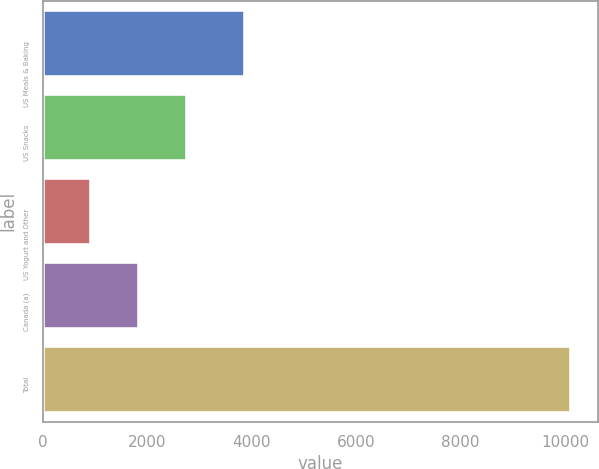Convert chart to OTSL. <chart><loc_0><loc_0><loc_500><loc_500><bar_chart><fcel>US Meals & Baking<fcel>US Snacks<fcel>US Yogurt and Other<fcel>Canada (a)<fcel>Total<nl><fcel>3865.7<fcel>2765<fcel>927.4<fcel>1846.2<fcel>10115.4<nl></chart> 